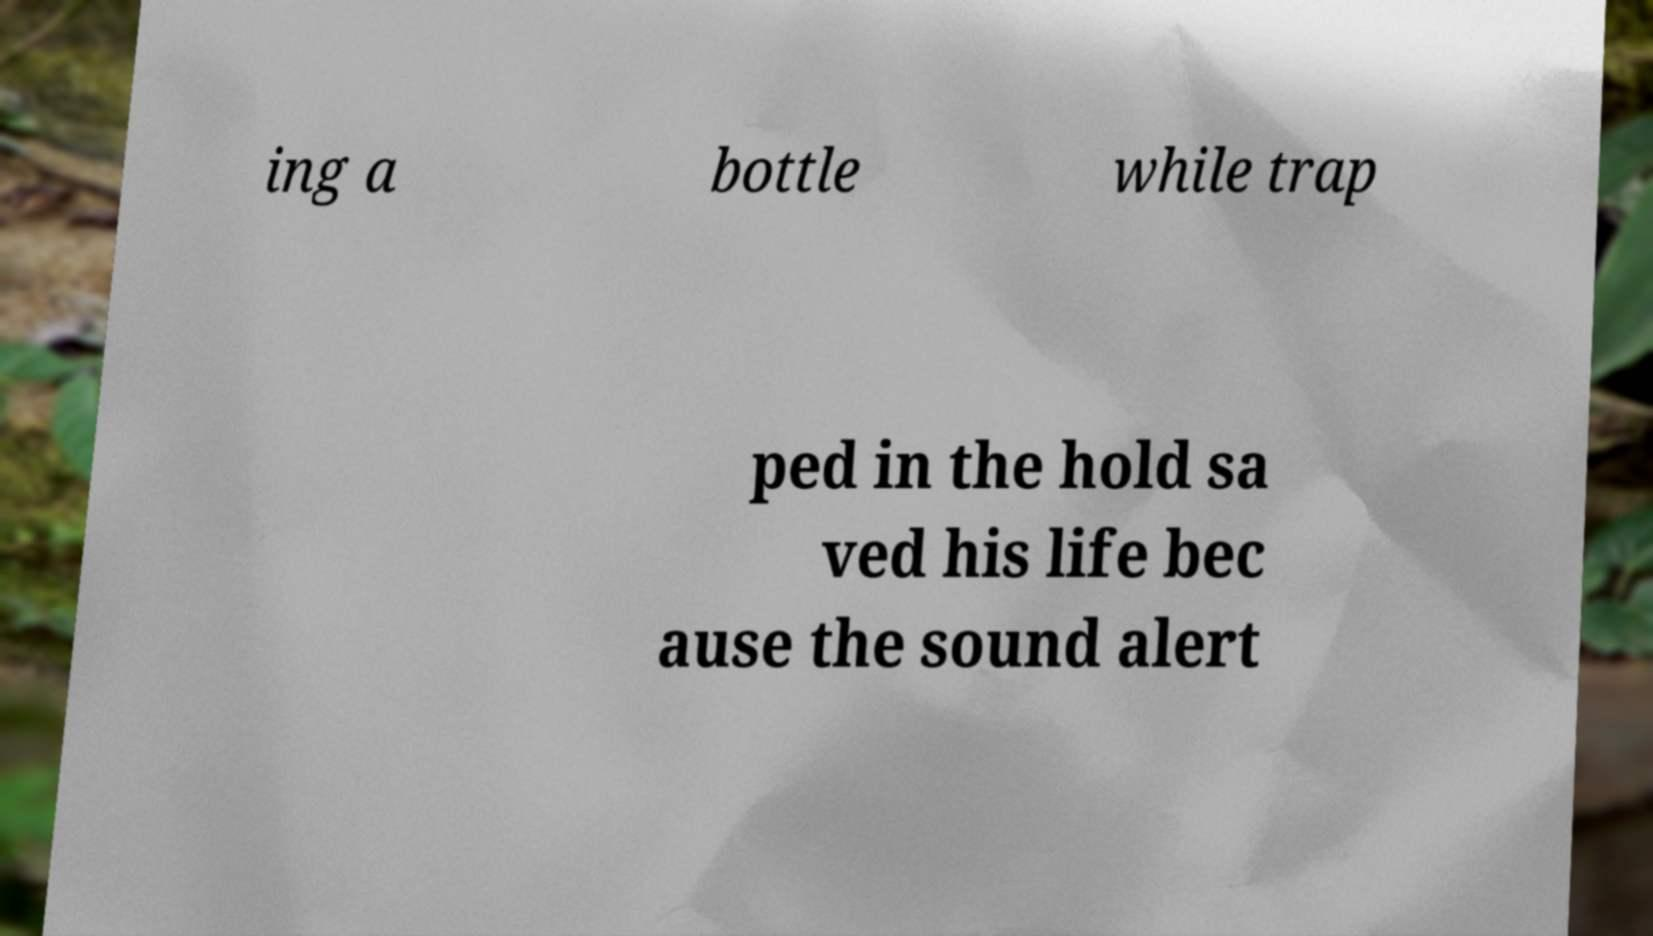I need the written content from this picture converted into text. Can you do that? ing a bottle while trap ped in the hold sa ved his life bec ause the sound alert 